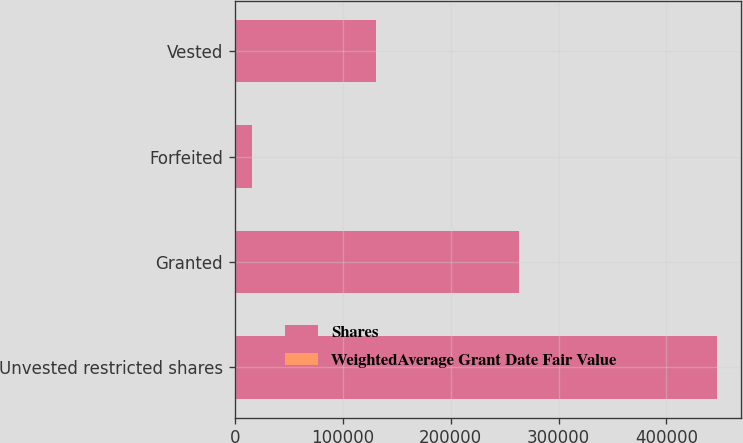Convert chart. <chart><loc_0><loc_0><loc_500><loc_500><stacked_bar_chart><ecel><fcel>Unvested restricted shares<fcel>Granted<fcel>Forfeited<fcel>Vested<nl><fcel>Shares<fcel>446978<fcel>263554<fcel>16100<fcel>131254<nl><fcel>WeightedAverage Grant Date Fair Value<fcel>28.59<fcel>33.55<fcel>21.5<fcel>14.61<nl></chart> 